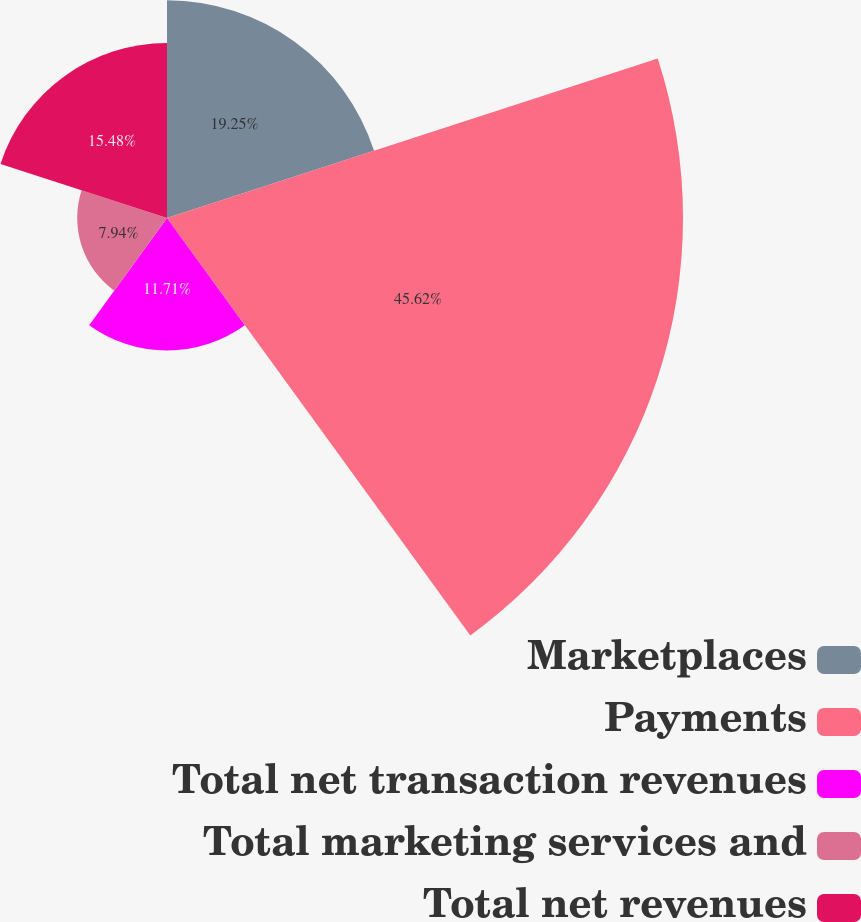Convert chart to OTSL. <chart><loc_0><loc_0><loc_500><loc_500><pie_chart><fcel>Marketplaces<fcel>Payments<fcel>Total net transaction revenues<fcel>Total marketing services and<fcel>Total net revenues<nl><fcel>19.25%<fcel>45.63%<fcel>11.71%<fcel>7.94%<fcel>15.48%<nl></chart> 